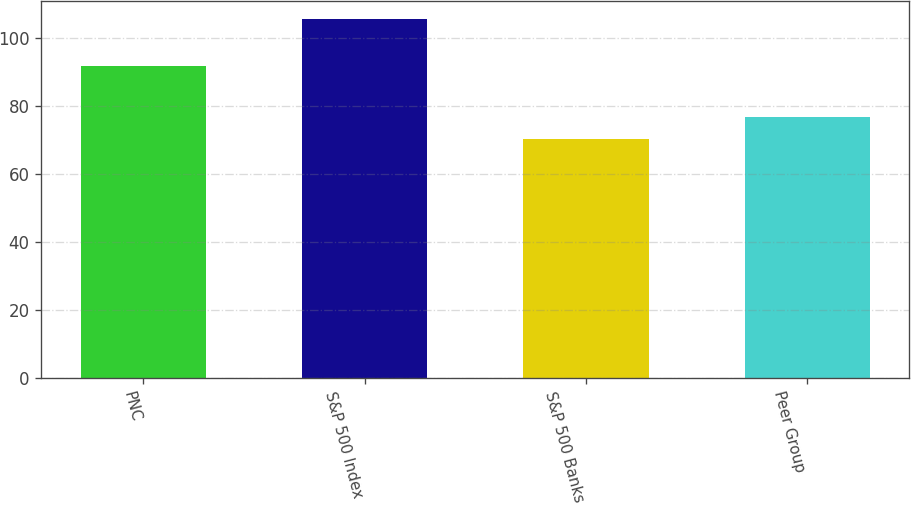Convert chart. <chart><loc_0><loc_0><loc_500><loc_500><bar_chart><fcel>PNC<fcel>S&P 500 Index<fcel>S&P 500 Banks<fcel>Peer Group<nl><fcel>91.71<fcel>105.49<fcel>70.22<fcel>76.73<nl></chart> 